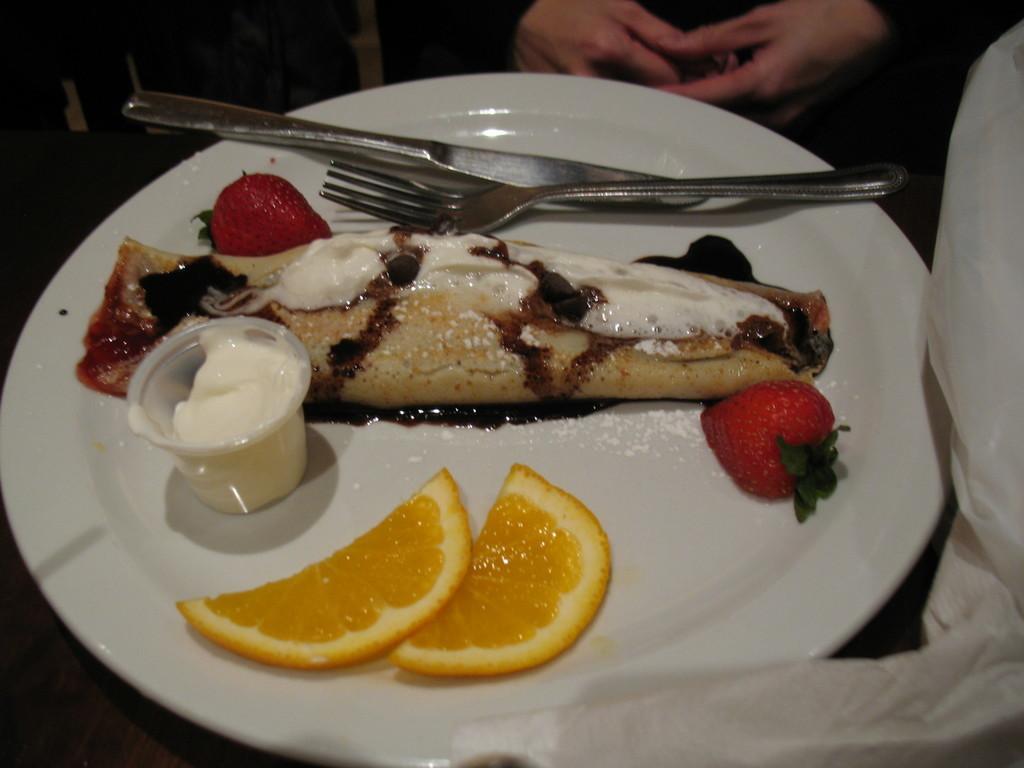Can you describe this image briefly? In this picture, there is a plate. On the plate, there is some food like strawberries, lemons, cream etc. On the plate, there is a fork and a knife. On the top, there is a person. 